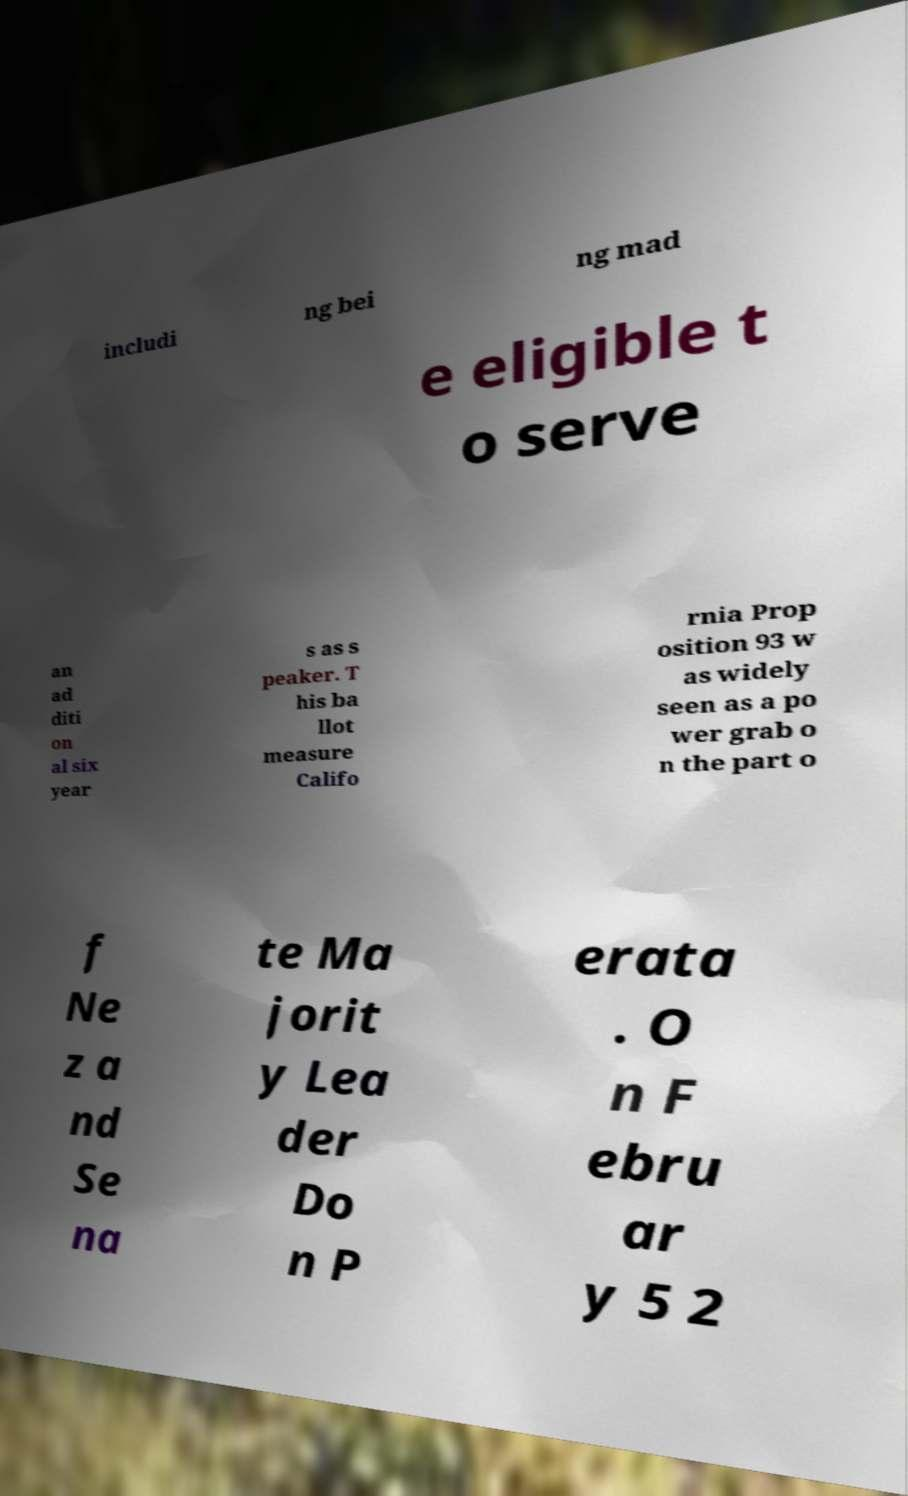There's text embedded in this image that I need extracted. Can you transcribe it verbatim? includi ng bei ng mad e eligible t o serve an ad diti on al six year s as s peaker. T his ba llot measure Califo rnia Prop osition 93 w as widely seen as a po wer grab o n the part o f Ne z a nd Se na te Ma jorit y Lea der Do n P erata . O n F ebru ar y 5 2 